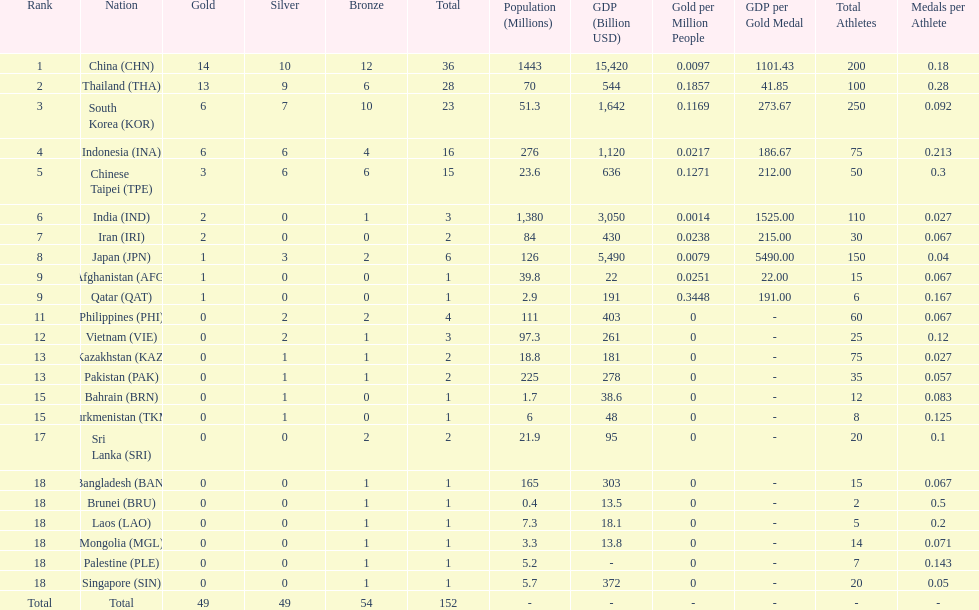Which nation finished first in total medals earned? China (CHN). 